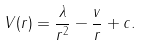Convert formula to latex. <formula><loc_0><loc_0><loc_500><loc_500>V ( r ) = \frac { \lambda } { r ^ { 2 } } - \frac { v } { r } + c .</formula> 